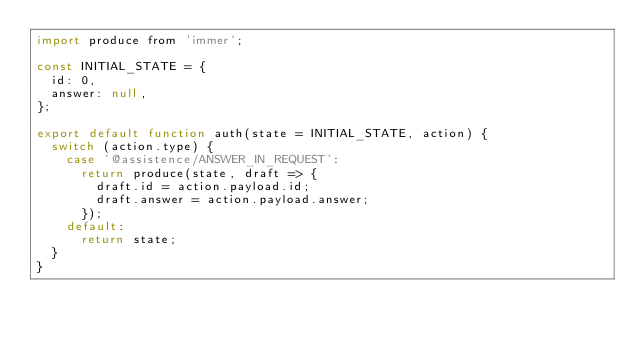Convert code to text. <code><loc_0><loc_0><loc_500><loc_500><_JavaScript_>import produce from 'immer';

const INITIAL_STATE = {
  id: 0,
  answer: null,
};

export default function auth(state = INITIAL_STATE, action) {
  switch (action.type) {
    case '@assistence/ANSWER_IN_REQUEST':
      return produce(state, draft => {
        draft.id = action.payload.id;
        draft.answer = action.payload.answer;
      });
    default:
      return state;
  }
}
</code> 